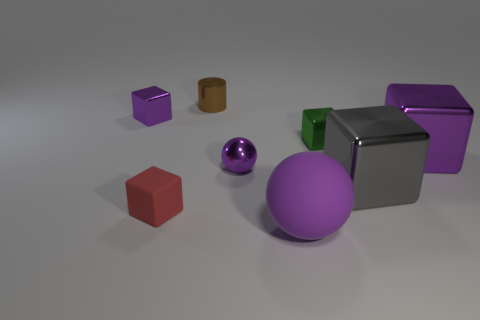The small green object has what shape?
Provide a succinct answer. Cube. How many tiny things are either metal balls or blocks?
Offer a very short reply. 4. What size is the other green thing that is the same shape as the small rubber object?
Ensure brevity in your answer.  Small. What number of purple things are both behind the big purple matte object and in front of the small green shiny cube?
Offer a terse response. 2. Is the shape of the small green object the same as the purple object to the left of the tiny red block?
Keep it short and to the point. Yes. Is the number of large gray things that are in front of the large purple ball greater than the number of tiny blue objects?
Provide a short and direct response. No. Are there fewer brown objects to the right of the brown cylinder than small purple matte cubes?
Offer a terse response. No. How many other large objects are the same color as the big matte thing?
Make the answer very short. 1. There is a block that is in front of the small purple metal sphere and on the left side of the small metallic ball; what is it made of?
Provide a succinct answer. Rubber. Does the rubber thing right of the tiny brown thing have the same color as the metallic block left of the green metallic object?
Keep it short and to the point. Yes. 